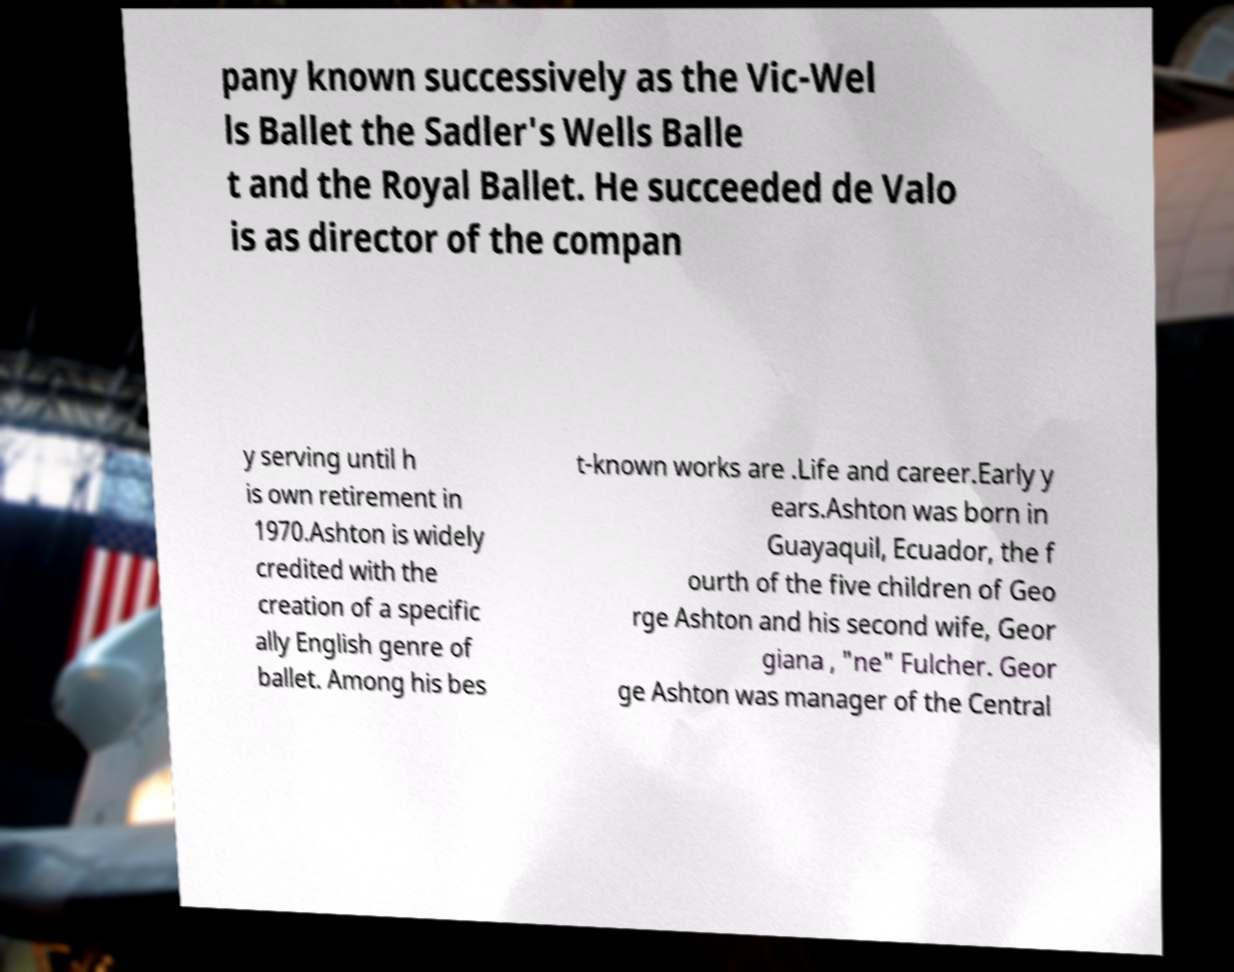Could you assist in decoding the text presented in this image and type it out clearly? pany known successively as the Vic-Wel ls Ballet the Sadler's Wells Balle t and the Royal Ballet. He succeeded de Valo is as director of the compan y serving until h is own retirement in 1970.Ashton is widely credited with the creation of a specific ally English genre of ballet. Among his bes t-known works are .Life and career.Early y ears.Ashton was born in Guayaquil, Ecuador, the f ourth of the five children of Geo rge Ashton and his second wife, Geor giana , "ne" Fulcher. Geor ge Ashton was manager of the Central 